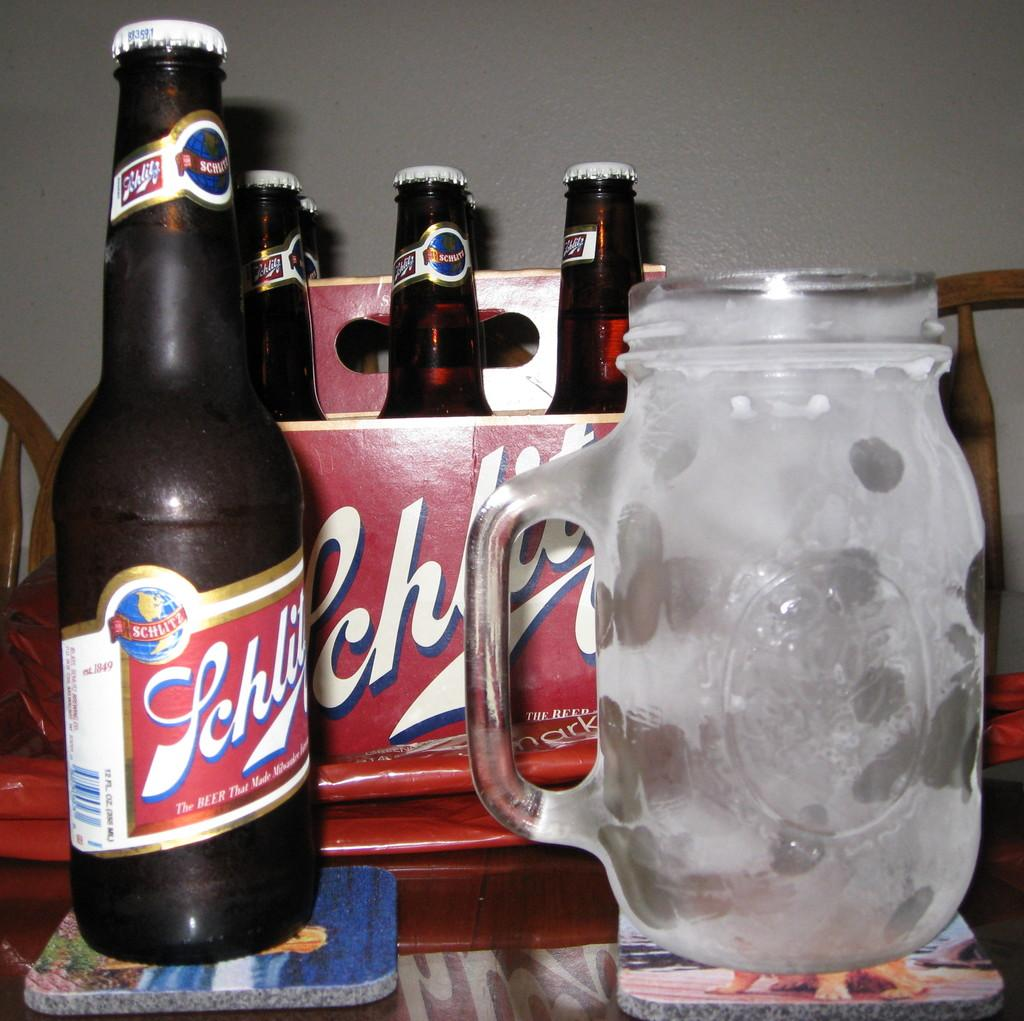<image>
Describe the image concisely. A six pack of Schlitz beer and a bottle of the beer on a coaster along side a frosty mug. 